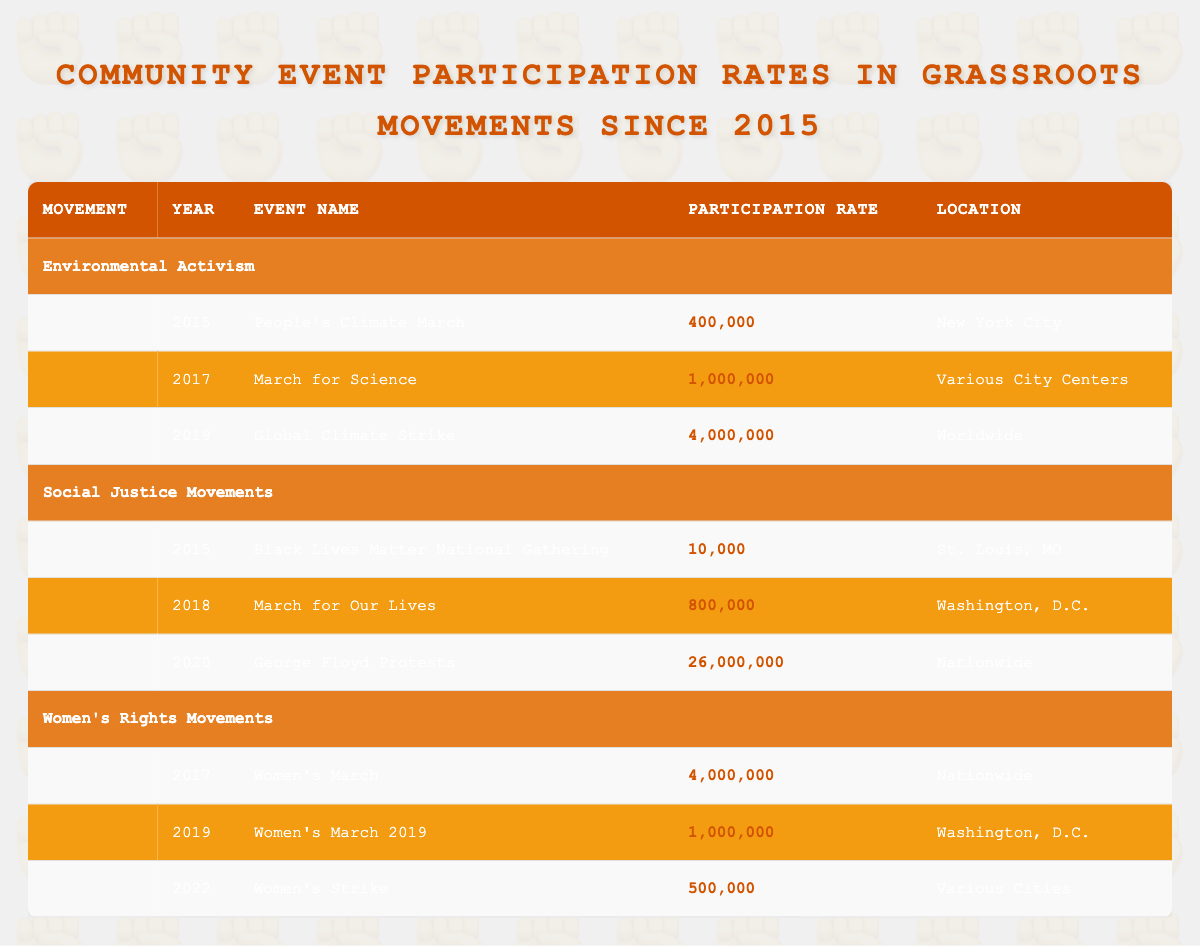What was the highest participation rate recorded in the environmental activism events? From the table, the highest participation rate under environmental activism is found in the Global Climate Strike in 2019, which has a rate of 4,000,000.
Answer: 4,000,000 Which event had the lowest participation rate in the social justice movements category? Looking into the social justice movements, the event with the lowest participation rate is the Black Lives Matter National Gathering in 2015, with a participation of 10,000.
Answer: 10,000 What is the total participation rate from women's rights movements from 2017 to 2022? To calculate the total, we add the participation rates of events from 2017 to 2022: Women's March (4,000,000) + Women's March 2019 (1,000,000) + Women's Strike (500,000) = 4,000,000 + 1,000,000 + 500,000 = 5,500,000.
Answer: 5,500,000 Did any grassroots movement event recorded over 25 million participants? Checking the table, the George Floyd Protests in 2020 had a participation rate of 26,000,000, which is indeed over 25 million, indicating that at least one event did reach this level.
Answer: Yes What was the average participation rate of all events in the social justice movements category? To find the average, sum the participation rates of all events: 10,000 (2015) + 800,000 (2018) + 26,000,000 (2020) = 26,810,000. There are three events, so the average is 26,810,000 / 3 = 8,936,666.67, which rounds to about 8,936,667.
Answer: 8,936,667 What was the total participation of events in 2019 across all movement categories? In 2019, the participation rates were: Global Climate Strike (4,000,000) for environmental activism and Women's March 2019 (1,000,000) for women's rights. Summing these gives 4,000,000 + 1,000,000 = 5,000,000.
Answer: 5,000,000 